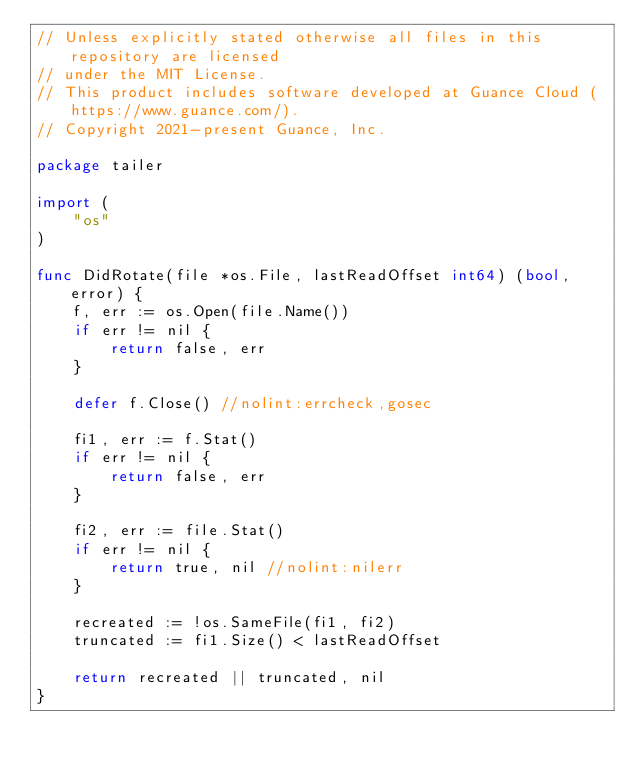Convert code to text. <code><loc_0><loc_0><loc_500><loc_500><_Go_>// Unless explicitly stated otherwise all files in this repository are licensed
// under the MIT License.
// This product includes software developed at Guance Cloud (https://www.guance.com/).
// Copyright 2021-present Guance, Inc.

package tailer

import (
	"os"
)

func DidRotate(file *os.File, lastReadOffset int64) (bool, error) {
	f, err := os.Open(file.Name())
	if err != nil {
		return false, err
	}

	defer f.Close() //nolint:errcheck,gosec

	fi1, err := f.Stat()
	if err != nil {
		return false, err
	}

	fi2, err := file.Stat()
	if err != nil {
		return true, nil //nolint:nilerr
	}

	recreated := !os.SameFile(fi1, fi2)
	truncated := fi1.Size() < lastReadOffset

	return recreated || truncated, nil
}
</code> 